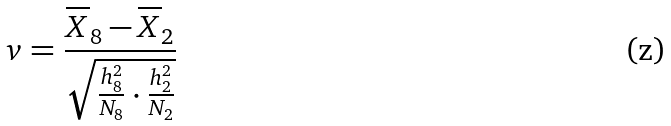Convert formula to latex. <formula><loc_0><loc_0><loc_500><loc_500>v = \frac { \overline { X } _ { 8 } - \overline { X } _ { 2 } } { \sqrt { \frac { h _ { 8 } ^ { 2 } } { N _ { 8 } } \cdot \frac { h _ { 2 } ^ { 2 } } { N _ { 2 } } } }</formula> 